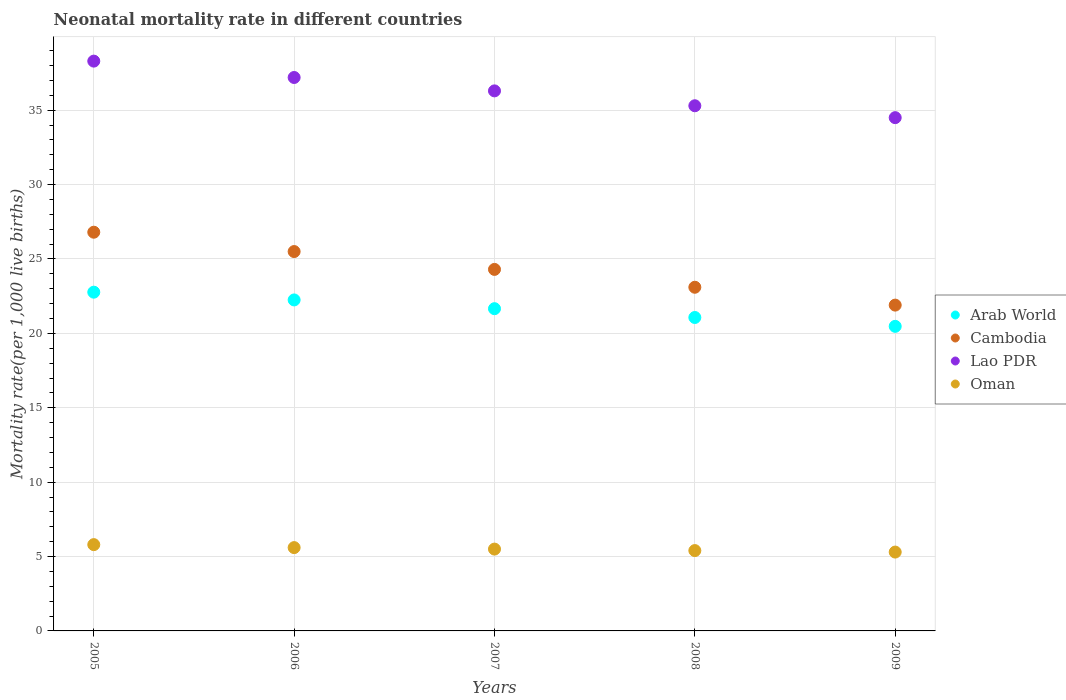What is the neonatal mortality rate in Arab World in 2007?
Offer a very short reply. 21.66. Across all years, what is the maximum neonatal mortality rate in Oman?
Your answer should be very brief. 5.8. Across all years, what is the minimum neonatal mortality rate in Cambodia?
Offer a very short reply. 21.9. In which year was the neonatal mortality rate in Arab World minimum?
Keep it short and to the point. 2009. What is the total neonatal mortality rate in Arab World in the graph?
Keep it short and to the point. 108.22. What is the difference between the neonatal mortality rate in Cambodia in 2006 and that in 2007?
Make the answer very short. 1.2. What is the difference between the neonatal mortality rate in Arab World in 2007 and the neonatal mortality rate in Oman in 2008?
Your response must be concise. 16.26. What is the average neonatal mortality rate in Cambodia per year?
Your response must be concise. 24.32. In the year 2009, what is the difference between the neonatal mortality rate in Lao PDR and neonatal mortality rate in Cambodia?
Offer a very short reply. 12.6. In how many years, is the neonatal mortality rate in Arab World greater than 37?
Make the answer very short. 0. What is the ratio of the neonatal mortality rate in Arab World in 2006 to that in 2009?
Provide a succinct answer. 1.09. Is the neonatal mortality rate in Arab World in 2005 less than that in 2008?
Ensure brevity in your answer.  No. What is the difference between the highest and the second highest neonatal mortality rate in Lao PDR?
Provide a short and direct response. 1.1. What is the difference between the highest and the lowest neonatal mortality rate in Cambodia?
Make the answer very short. 4.9. In how many years, is the neonatal mortality rate in Cambodia greater than the average neonatal mortality rate in Cambodia taken over all years?
Your answer should be very brief. 2. Is the sum of the neonatal mortality rate in Lao PDR in 2006 and 2008 greater than the maximum neonatal mortality rate in Oman across all years?
Keep it short and to the point. Yes. Is it the case that in every year, the sum of the neonatal mortality rate in Oman and neonatal mortality rate in Cambodia  is greater than the sum of neonatal mortality rate in Arab World and neonatal mortality rate in Lao PDR?
Keep it short and to the point. No. Is it the case that in every year, the sum of the neonatal mortality rate in Arab World and neonatal mortality rate in Cambodia  is greater than the neonatal mortality rate in Oman?
Provide a short and direct response. Yes. Is the neonatal mortality rate in Oman strictly greater than the neonatal mortality rate in Arab World over the years?
Provide a succinct answer. No. How many dotlines are there?
Give a very brief answer. 4. How many years are there in the graph?
Make the answer very short. 5. How many legend labels are there?
Offer a terse response. 4. How are the legend labels stacked?
Offer a terse response. Vertical. What is the title of the graph?
Provide a succinct answer. Neonatal mortality rate in different countries. What is the label or title of the Y-axis?
Your response must be concise. Mortality rate(per 1,0 live births). What is the Mortality rate(per 1,000 live births) in Arab World in 2005?
Your response must be concise. 22.77. What is the Mortality rate(per 1,000 live births) of Cambodia in 2005?
Your answer should be compact. 26.8. What is the Mortality rate(per 1,000 live births) of Lao PDR in 2005?
Provide a succinct answer. 38.3. What is the Mortality rate(per 1,000 live births) in Oman in 2005?
Provide a succinct answer. 5.8. What is the Mortality rate(per 1,000 live births) of Arab World in 2006?
Offer a terse response. 22.25. What is the Mortality rate(per 1,000 live births) in Lao PDR in 2006?
Provide a short and direct response. 37.2. What is the Mortality rate(per 1,000 live births) in Oman in 2006?
Your answer should be compact. 5.6. What is the Mortality rate(per 1,000 live births) in Arab World in 2007?
Keep it short and to the point. 21.66. What is the Mortality rate(per 1,000 live births) in Cambodia in 2007?
Give a very brief answer. 24.3. What is the Mortality rate(per 1,000 live births) of Lao PDR in 2007?
Offer a terse response. 36.3. What is the Mortality rate(per 1,000 live births) in Arab World in 2008?
Your response must be concise. 21.07. What is the Mortality rate(per 1,000 live births) in Cambodia in 2008?
Offer a very short reply. 23.1. What is the Mortality rate(per 1,000 live births) in Lao PDR in 2008?
Give a very brief answer. 35.3. What is the Mortality rate(per 1,000 live births) in Arab World in 2009?
Your response must be concise. 20.47. What is the Mortality rate(per 1,000 live births) of Cambodia in 2009?
Make the answer very short. 21.9. What is the Mortality rate(per 1,000 live births) in Lao PDR in 2009?
Make the answer very short. 34.5. Across all years, what is the maximum Mortality rate(per 1,000 live births) of Arab World?
Offer a very short reply. 22.77. Across all years, what is the maximum Mortality rate(per 1,000 live births) of Cambodia?
Make the answer very short. 26.8. Across all years, what is the maximum Mortality rate(per 1,000 live births) of Lao PDR?
Make the answer very short. 38.3. Across all years, what is the minimum Mortality rate(per 1,000 live births) in Arab World?
Your answer should be very brief. 20.47. Across all years, what is the minimum Mortality rate(per 1,000 live births) in Cambodia?
Offer a very short reply. 21.9. Across all years, what is the minimum Mortality rate(per 1,000 live births) of Lao PDR?
Ensure brevity in your answer.  34.5. What is the total Mortality rate(per 1,000 live births) in Arab World in the graph?
Make the answer very short. 108.22. What is the total Mortality rate(per 1,000 live births) of Cambodia in the graph?
Give a very brief answer. 121.6. What is the total Mortality rate(per 1,000 live births) of Lao PDR in the graph?
Provide a short and direct response. 181.6. What is the total Mortality rate(per 1,000 live births) in Oman in the graph?
Keep it short and to the point. 27.6. What is the difference between the Mortality rate(per 1,000 live births) of Arab World in 2005 and that in 2006?
Provide a succinct answer. 0.52. What is the difference between the Mortality rate(per 1,000 live births) in Cambodia in 2005 and that in 2006?
Provide a succinct answer. 1.3. What is the difference between the Mortality rate(per 1,000 live births) in Arab World in 2005 and that in 2007?
Make the answer very short. 1.11. What is the difference between the Mortality rate(per 1,000 live births) of Lao PDR in 2005 and that in 2007?
Provide a succinct answer. 2. What is the difference between the Mortality rate(per 1,000 live births) in Oman in 2005 and that in 2007?
Give a very brief answer. 0.3. What is the difference between the Mortality rate(per 1,000 live births) in Arab World in 2005 and that in 2008?
Offer a terse response. 1.7. What is the difference between the Mortality rate(per 1,000 live births) of Cambodia in 2005 and that in 2008?
Keep it short and to the point. 3.7. What is the difference between the Mortality rate(per 1,000 live births) of Oman in 2005 and that in 2008?
Your answer should be compact. 0.4. What is the difference between the Mortality rate(per 1,000 live births) of Arab World in 2005 and that in 2009?
Offer a very short reply. 2.3. What is the difference between the Mortality rate(per 1,000 live births) in Lao PDR in 2005 and that in 2009?
Your response must be concise. 3.8. What is the difference between the Mortality rate(per 1,000 live births) in Arab World in 2006 and that in 2007?
Give a very brief answer. 0.59. What is the difference between the Mortality rate(per 1,000 live births) in Cambodia in 2006 and that in 2007?
Ensure brevity in your answer.  1.2. What is the difference between the Mortality rate(per 1,000 live births) of Lao PDR in 2006 and that in 2007?
Provide a succinct answer. 0.9. What is the difference between the Mortality rate(per 1,000 live births) in Arab World in 2006 and that in 2008?
Give a very brief answer. 1.18. What is the difference between the Mortality rate(per 1,000 live births) in Arab World in 2006 and that in 2009?
Provide a succinct answer. 1.78. What is the difference between the Mortality rate(per 1,000 live births) of Cambodia in 2006 and that in 2009?
Provide a succinct answer. 3.6. What is the difference between the Mortality rate(per 1,000 live births) in Oman in 2006 and that in 2009?
Ensure brevity in your answer.  0.3. What is the difference between the Mortality rate(per 1,000 live births) of Arab World in 2007 and that in 2008?
Offer a very short reply. 0.59. What is the difference between the Mortality rate(per 1,000 live births) in Arab World in 2007 and that in 2009?
Your answer should be compact. 1.19. What is the difference between the Mortality rate(per 1,000 live births) in Cambodia in 2007 and that in 2009?
Offer a terse response. 2.4. What is the difference between the Mortality rate(per 1,000 live births) in Oman in 2007 and that in 2009?
Provide a succinct answer. 0.2. What is the difference between the Mortality rate(per 1,000 live births) of Arab World in 2008 and that in 2009?
Give a very brief answer. 0.6. What is the difference between the Mortality rate(per 1,000 live births) of Oman in 2008 and that in 2009?
Ensure brevity in your answer.  0.1. What is the difference between the Mortality rate(per 1,000 live births) in Arab World in 2005 and the Mortality rate(per 1,000 live births) in Cambodia in 2006?
Make the answer very short. -2.73. What is the difference between the Mortality rate(per 1,000 live births) of Arab World in 2005 and the Mortality rate(per 1,000 live births) of Lao PDR in 2006?
Your answer should be compact. -14.43. What is the difference between the Mortality rate(per 1,000 live births) in Arab World in 2005 and the Mortality rate(per 1,000 live births) in Oman in 2006?
Your answer should be compact. 17.17. What is the difference between the Mortality rate(per 1,000 live births) of Cambodia in 2005 and the Mortality rate(per 1,000 live births) of Lao PDR in 2006?
Your response must be concise. -10.4. What is the difference between the Mortality rate(per 1,000 live births) in Cambodia in 2005 and the Mortality rate(per 1,000 live births) in Oman in 2006?
Make the answer very short. 21.2. What is the difference between the Mortality rate(per 1,000 live births) in Lao PDR in 2005 and the Mortality rate(per 1,000 live births) in Oman in 2006?
Make the answer very short. 32.7. What is the difference between the Mortality rate(per 1,000 live births) in Arab World in 2005 and the Mortality rate(per 1,000 live births) in Cambodia in 2007?
Your answer should be compact. -1.53. What is the difference between the Mortality rate(per 1,000 live births) in Arab World in 2005 and the Mortality rate(per 1,000 live births) in Lao PDR in 2007?
Provide a succinct answer. -13.53. What is the difference between the Mortality rate(per 1,000 live births) of Arab World in 2005 and the Mortality rate(per 1,000 live births) of Oman in 2007?
Keep it short and to the point. 17.27. What is the difference between the Mortality rate(per 1,000 live births) of Cambodia in 2005 and the Mortality rate(per 1,000 live births) of Oman in 2007?
Make the answer very short. 21.3. What is the difference between the Mortality rate(per 1,000 live births) in Lao PDR in 2005 and the Mortality rate(per 1,000 live births) in Oman in 2007?
Offer a very short reply. 32.8. What is the difference between the Mortality rate(per 1,000 live births) of Arab World in 2005 and the Mortality rate(per 1,000 live births) of Cambodia in 2008?
Give a very brief answer. -0.33. What is the difference between the Mortality rate(per 1,000 live births) of Arab World in 2005 and the Mortality rate(per 1,000 live births) of Lao PDR in 2008?
Provide a succinct answer. -12.53. What is the difference between the Mortality rate(per 1,000 live births) in Arab World in 2005 and the Mortality rate(per 1,000 live births) in Oman in 2008?
Ensure brevity in your answer.  17.37. What is the difference between the Mortality rate(per 1,000 live births) of Cambodia in 2005 and the Mortality rate(per 1,000 live births) of Oman in 2008?
Provide a short and direct response. 21.4. What is the difference between the Mortality rate(per 1,000 live births) of Lao PDR in 2005 and the Mortality rate(per 1,000 live births) of Oman in 2008?
Provide a succinct answer. 32.9. What is the difference between the Mortality rate(per 1,000 live births) of Arab World in 2005 and the Mortality rate(per 1,000 live births) of Cambodia in 2009?
Your answer should be very brief. 0.87. What is the difference between the Mortality rate(per 1,000 live births) of Arab World in 2005 and the Mortality rate(per 1,000 live births) of Lao PDR in 2009?
Give a very brief answer. -11.73. What is the difference between the Mortality rate(per 1,000 live births) in Arab World in 2005 and the Mortality rate(per 1,000 live births) in Oman in 2009?
Provide a short and direct response. 17.47. What is the difference between the Mortality rate(per 1,000 live births) in Cambodia in 2005 and the Mortality rate(per 1,000 live births) in Oman in 2009?
Ensure brevity in your answer.  21.5. What is the difference between the Mortality rate(per 1,000 live births) of Lao PDR in 2005 and the Mortality rate(per 1,000 live births) of Oman in 2009?
Keep it short and to the point. 33. What is the difference between the Mortality rate(per 1,000 live births) in Arab World in 2006 and the Mortality rate(per 1,000 live births) in Cambodia in 2007?
Make the answer very short. -2.05. What is the difference between the Mortality rate(per 1,000 live births) of Arab World in 2006 and the Mortality rate(per 1,000 live births) of Lao PDR in 2007?
Offer a very short reply. -14.05. What is the difference between the Mortality rate(per 1,000 live births) in Arab World in 2006 and the Mortality rate(per 1,000 live births) in Oman in 2007?
Make the answer very short. 16.75. What is the difference between the Mortality rate(per 1,000 live births) in Lao PDR in 2006 and the Mortality rate(per 1,000 live births) in Oman in 2007?
Offer a terse response. 31.7. What is the difference between the Mortality rate(per 1,000 live births) in Arab World in 2006 and the Mortality rate(per 1,000 live births) in Cambodia in 2008?
Offer a terse response. -0.85. What is the difference between the Mortality rate(per 1,000 live births) in Arab World in 2006 and the Mortality rate(per 1,000 live births) in Lao PDR in 2008?
Offer a terse response. -13.05. What is the difference between the Mortality rate(per 1,000 live births) of Arab World in 2006 and the Mortality rate(per 1,000 live births) of Oman in 2008?
Provide a short and direct response. 16.85. What is the difference between the Mortality rate(per 1,000 live births) of Cambodia in 2006 and the Mortality rate(per 1,000 live births) of Oman in 2008?
Your answer should be very brief. 20.1. What is the difference between the Mortality rate(per 1,000 live births) in Lao PDR in 2006 and the Mortality rate(per 1,000 live births) in Oman in 2008?
Your answer should be very brief. 31.8. What is the difference between the Mortality rate(per 1,000 live births) in Arab World in 2006 and the Mortality rate(per 1,000 live births) in Cambodia in 2009?
Ensure brevity in your answer.  0.35. What is the difference between the Mortality rate(per 1,000 live births) in Arab World in 2006 and the Mortality rate(per 1,000 live births) in Lao PDR in 2009?
Your answer should be compact. -12.25. What is the difference between the Mortality rate(per 1,000 live births) in Arab World in 2006 and the Mortality rate(per 1,000 live births) in Oman in 2009?
Offer a terse response. 16.95. What is the difference between the Mortality rate(per 1,000 live births) of Cambodia in 2006 and the Mortality rate(per 1,000 live births) of Oman in 2009?
Provide a short and direct response. 20.2. What is the difference between the Mortality rate(per 1,000 live births) of Lao PDR in 2006 and the Mortality rate(per 1,000 live births) of Oman in 2009?
Offer a terse response. 31.9. What is the difference between the Mortality rate(per 1,000 live births) of Arab World in 2007 and the Mortality rate(per 1,000 live births) of Cambodia in 2008?
Ensure brevity in your answer.  -1.44. What is the difference between the Mortality rate(per 1,000 live births) in Arab World in 2007 and the Mortality rate(per 1,000 live births) in Lao PDR in 2008?
Your response must be concise. -13.64. What is the difference between the Mortality rate(per 1,000 live births) of Arab World in 2007 and the Mortality rate(per 1,000 live births) of Oman in 2008?
Make the answer very short. 16.26. What is the difference between the Mortality rate(per 1,000 live births) in Lao PDR in 2007 and the Mortality rate(per 1,000 live births) in Oman in 2008?
Provide a short and direct response. 30.9. What is the difference between the Mortality rate(per 1,000 live births) of Arab World in 2007 and the Mortality rate(per 1,000 live births) of Cambodia in 2009?
Give a very brief answer. -0.24. What is the difference between the Mortality rate(per 1,000 live births) in Arab World in 2007 and the Mortality rate(per 1,000 live births) in Lao PDR in 2009?
Give a very brief answer. -12.84. What is the difference between the Mortality rate(per 1,000 live births) in Arab World in 2007 and the Mortality rate(per 1,000 live births) in Oman in 2009?
Give a very brief answer. 16.36. What is the difference between the Mortality rate(per 1,000 live births) of Cambodia in 2007 and the Mortality rate(per 1,000 live births) of Lao PDR in 2009?
Keep it short and to the point. -10.2. What is the difference between the Mortality rate(per 1,000 live births) in Cambodia in 2007 and the Mortality rate(per 1,000 live births) in Oman in 2009?
Your answer should be very brief. 19. What is the difference between the Mortality rate(per 1,000 live births) in Lao PDR in 2007 and the Mortality rate(per 1,000 live births) in Oman in 2009?
Offer a terse response. 31. What is the difference between the Mortality rate(per 1,000 live births) of Arab World in 2008 and the Mortality rate(per 1,000 live births) of Cambodia in 2009?
Give a very brief answer. -0.83. What is the difference between the Mortality rate(per 1,000 live births) in Arab World in 2008 and the Mortality rate(per 1,000 live births) in Lao PDR in 2009?
Keep it short and to the point. -13.43. What is the difference between the Mortality rate(per 1,000 live births) in Arab World in 2008 and the Mortality rate(per 1,000 live births) in Oman in 2009?
Ensure brevity in your answer.  15.77. What is the difference between the Mortality rate(per 1,000 live births) in Cambodia in 2008 and the Mortality rate(per 1,000 live births) in Oman in 2009?
Give a very brief answer. 17.8. What is the difference between the Mortality rate(per 1,000 live births) of Lao PDR in 2008 and the Mortality rate(per 1,000 live births) of Oman in 2009?
Make the answer very short. 30. What is the average Mortality rate(per 1,000 live births) in Arab World per year?
Keep it short and to the point. 21.64. What is the average Mortality rate(per 1,000 live births) of Cambodia per year?
Your answer should be very brief. 24.32. What is the average Mortality rate(per 1,000 live births) of Lao PDR per year?
Your answer should be very brief. 36.32. What is the average Mortality rate(per 1,000 live births) of Oman per year?
Ensure brevity in your answer.  5.52. In the year 2005, what is the difference between the Mortality rate(per 1,000 live births) of Arab World and Mortality rate(per 1,000 live births) of Cambodia?
Provide a succinct answer. -4.03. In the year 2005, what is the difference between the Mortality rate(per 1,000 live births) of Arab World and Mortality rate(per 1,000 live births) of Lao PDR?
Offer a very short reply. -15.53. In the year 2005, what is the difference between the Mortality rate(per 1,000 live births) in Arab World and Mortality rate(per 1,000 live births) in Oman?
Your answer should be very brief. 16.97. In the year 2005, what is the difference between the Mortality rate(per 1,000 live births) of Cambodia and Mortality rate(per 1,000 live births) of Lao PDR?
Your answer should be compact. -11.5. In the year 2005, what is the difference between the Mortality rate(per 1,000 live births) in Lao PDR and Mortality rate(per 1,000 live births) in Oman?
Your answer should be compact. 32.5. In the year 2006, what is the difference between the Mortality rate(per 1,000 live births) of Arab World and Mortality rate(per 1,000 live births) of Cambodia?
Offer a terse response. -3.25. In the year 2006, what is the difference between the Mortality rate(per 1,000 live births) in Arab World and Mortality rate(per 1,000 live births) in Lao PDR?
Give a very brief answer. -14.95. In the year 2006, what is the difference between the Mortality rate(per 1,000 live births) of Arab World and Mortality rate(per 1,000 live births) of Oman?
Your response must be concise. 16.65. In the year 2006, what is the difference between the Mortality rate(per 1,000 live births) of Lao PDR and Mortality rate(per 1,000 live births) of Oman?
Your response must be concise. 31.6. In the year 2007, what is the difference between the Mortality rate(per 1,000 live births) in Arab World and Mortality rate(per 1,000 live births) in Cambodia?
Make the answer very short. -2.64. In the year 2007, what is the difference between the Mortality rate(per 1,000 live births) of Arab World and Mortality rate(per 1,000 live births) of Lao PDR?
Your response must be concise. -14.64. In the year 2007, what is the difference between the Mortality rate(per 1,000 live births) in Arab World and Mortality rate(per 1,000 live births) in Oman?
Make the answer very short. 16.16. In the year 2007, what is the difference between the Mortality rate(per 1,000 live births) in Cambodia and Mortality rate(per 1,000 live births) in Lao PDR?
Your answer should be very brief. -12. In the year 2007, what is the difference between the Mortality rate(per 1,000 live births) of Cambodia and Mortality rate(per 1,000 live births) of Oman?
Provide a short and direct response. 18.8. In the year 2007, what is the difference between the Mortality rate(per 1,000 live births) of Lao PDR and Mortality rate(per 1,000 live births) of Oman?
Offer a terse response. 30.8. In the year 2008, what is the difference between the Mortality rate(per 1,000 live births) of Arab World and Mortality rate(per 1,000 live births) of Cambodia?
Ensure brevity in your answer.  -2.03. In the year 2008, what is the difference between the Mortality rate(per 1,000 live births) of Arab World and Mortality rate(per 1,000 live births) of Lao PDR?
Ensure brevity in your answer.  -14.23. In the year 2008, what is the difference between the Mortality rate(per 1,000 live births) in Arab World and Mortality rate(per 1,000 live births) in Oman?
Provide a short and direct response. 15.67. In the year 2008, what is the difference between the Mortality rate(per 1,000 live births) of Cambodia and Mortality rate(per 1,000 live births) of Lao PDR?
Offer a terse response. -12.2. In the year 2008, what is the difference between the Mortality rate(per 1,000 live births) in Cambodia and Mortality rate(per 1,000 live births) in Oman?
Provide a short and direct response. 17.7. In the year 2008, what is the difference between the Mortality rate(per 1,000 live births) of Lao PDR and Mortality rate(per 1,000 live births) of Oman?
Provide a succinct answer. 29.9. In the year 2009, what is the difference between the Mortality rate(per 1,000 live births) in Arab World and Mortality rate(per 1,000 live births) in Cambodia?
Offer a very short reply. -1.43. In the year 2009, what is the difference between the Mortality rate(per 1,000 live births) in Arab World and Mortality rate(per 1,000 live births) in Lao PDR?
Provide a short and direct response. -14.03. In the year 2009, what is the difference between the Mortality rate(per 1,000 live births) of Arab World and Mortality rate(per 1,000 live births) of Oman?
Ensure brevity in your answer.  15.17. In the year 2009, what is the difference between the Mortality rate(per 1,000 live births) in Lao PDR and Mortality rate(per 1,000 live births) in Oman?
Offer a terse response. 29.2. What is the ratio of the Mortality rate(per 1,000 live births) of Arab World in 2005 to that in 2006?
Your response must be concise. 1.02. What is the ratio of the Mortality rate(per 1,000 live births) of Cambodia in 2005 to that in 2006?
Your answer should be very brief. 1.05. What is the ratio of the Mortality rate(per 1,000 live births) of Lao PDR in 2005 to that in 2006?
Your answer should be compact. 1.03. What is the ratio of the Mortality rate(per 1,000 live births) of Oman in 2005 to that in 2006?
Your response must be concise. 1.04. What is the ratio of the Mortality rate(per 1,000 live births) of Arab World in 2005 to that in 2007?
Your answer should be compact. 1.05. What is the ratio of the Mortality rate(per 1,000 live births) of Cambodia in 2005 to that in 2007?
Keep it short and to the point. 1.1. What is the ratio of the Mortality rate(per 1,000 live births) in Lao PDR in 2005 to that in 2007?
Keep it short and to the point. 1.06. What is the ratio of the Mortality rate(per 1,000 live births) of Oman in 2005 to that in 2007?
Give a very brief answer. 1.05. What is the ratio of the Mortality rate(per 1,000 live births) in Arab World in 2005 to that in 2008?
Your answer should be very brief. 1.08. What is the ratio of the Mortality rate(per 1,000 live births) of Cambodia in 2005 to that in 2008?
Provide a succinct answer. 1.16. What is the ratio of the Mortality rate(per 1,000 live births) of Lao PDR in 2005 to that in 2008?
Provide a short and direct response. 1.08. What is the ratio of the Mortality rate(per 1,000 live births) in Oman in 2005 to that in 2008?
Ensure brevity in your answer.  1.07. What is the ratio of the Mortality rate(per 1,000 live births) in Arab World in 2005 to that in 2009?
Make the answer very short. 1.11. What is the ratio of the Mortality rate(per 1,000 live births) of Cambodia in 2005 to that in 2009?
Provide a short and direct response. 1.22. What is the ratio of the Mortality rate(per 1,000 live births) in Lao PDR in 2005 to that in 2009?
Make the answer very short. 1.11. What is the ratio of the Mortality rate(per 1,000 live births) in Oman in 2005 to that in 2009?
Keep it short and to the point. 1.09. What is the ratio of the Mortality rate(per 1,000 live births) of Arab World in 2006 to that in 2007?
Provide a succinct answer. 1.03. What is the ratio of the Mortality rate(per 1,000 live births) in Cambodia in 2006 to that in 2007?
Keep it short and to the point. 1.05. What is the ratio of the Mortality rate(per 1,000 live births) of Lao PDR in 2006 to that in 2007?
Ensure brevity in your answer.  1.02. What is the ratio of the Mortality rate(per 1,000 live births) of Oman in 2006 to that in 2007?
Offer a very short reply. 1.02. What is the ratio of the Mortality rate(per 1,000 live births) in Arab World in 2006 to that in 2008?
Ensure brevity in your answer.  1.06. What is the ratio of the Mortality rate(per 1,000 live births) of Cambodia in 2006 to that in 2008?
Make the answer very short. 1.1. What is the ratio of the Mortality rate(per 1,000 live births) of Lao PDR in 2006 to that in 2008?
Your response must be concise. 1.05. What is the ratio of the Mortality rate(per 1,000 live births) of Oman in 2006 to that in 2008?
Make the answer very short. 1.04. What is the ratio of the Mortality rate(per 1,000 live births) of Arab World in 2006 to that in 2009?
Offer a very short reply. 1.09. What is the ratio of the Mortality rate(per 1,000 live births) of Cambodia in 2006 to that in 2009?
Offer a very short reply. 1.16. What is the ratio of the Mortality rate(per 1,000 live births) in Lao PDR in 2006 to that in 2009?
Your answer should be compact. 1.08. What is the ratio of the Mortality rate(per 1,000 live births) in Oman in 2006 to that in 2009?
Provide a short and direct response. 1.06. What is the ratio of the Mortality rate(per 1,000 live births) in Arab World in 2007 to that in 2008?
Offer a very short reply. 1.03. What is the ratio of the Mortality rate(per 1,000 live births) in Cambodia in 2007 to that in 2008?
Offer a very short reply. 1.05. What is the ratio of the Mortality rate(per 1,000 live births) of Lao PDR in 2007 to that in 2008?
Offer a very short reply. 1.03. What is the ratio of the Mortality rate(per 1,000 live births) in Oman in 2007 to that in 2008?
Give a very brief answer. 1.02. What is the ratio of the Mortality rate(per 1,000 live births) of Arab World in 2007 to that in 2009?
Provide a succinct answer. 1.06. What is the ratio of the Mortality rate(per 1,000 live births) in Cambodia in 2007 to that in 2009?
Keep it short and to the point. 1.11. What is the ratio of the Mortality rate(per 1,000 live births) in Lao PDR in 2007 to that in 2009?
Keep it short and to the point. 1.05. What is the ratio of the Mortality rate(per 1,000 live births) in Oman in 2007 to that in 2009?
Your response must be concise. 1.04. What is the ratio of the Mortality rate(per 1,000 live births) in Arab World in 2008 to that in 2009?
Give a very brief answer. 1.03. What is the ratio of the Mortality rate(per 1,000 live births) in Cambodia in 2008 to that in 2009?
Ensure brevity in your answer.  1.05. What is the ratio of the Mortality rate(per 1,000 live births) of Lao PDR in 2008 to that in 2009?
Offer a terse response. 1.02. What is the ratio of the Mortality rate(per 1,000 live births) in Oman in 2008 to that in 2009?
Provide a short and direct response. 1.02. What is the difference between the highest and the second highest Mortality rate(per 1,000 live births) in Arab World?
Your response must be concise. 0.52. What is the difference between the highest and the second highest Mortality rate(per 1,000 live births) in Cambodia?
Provide a succinct answer. 1.3. What is the difference between the highest and the second highest Mortality rate(per 1,000 live births) in Lao PDR?
Give a very brief answer. 1.1. What is the difference between the highest and the lowest Mortality rate(per 1,000 live births) of Arab World?
Offer a terse response. 2.3. What is the difference between the highest and the lowest Mortality rate(per 1,000 live births) in Cambodia?
Give a very brief answer. 4.9. 